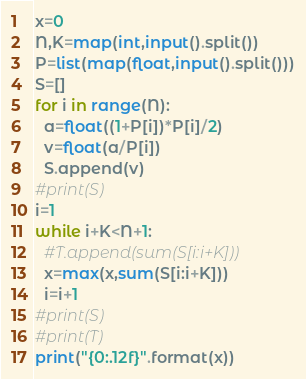Convert code to text. <code><loc_0><loc_0><loc_500><loc_500><_Python_>x=0
N,K=map(int,input().split())
P=list(map(float,input().split()))
S=[]
for i in range(N):
  a=float((1+P[i])*P[i]/2)
  v=float(a/P[i])
  S.append(v)
#print(S)
i=1
while i+K<N+1:
  #T.append(sum(S[i:i+K]))
  x=max(x,sum(S[i:i+K]))
  i=i+1
#print(S)
#print(T)
print("{0:.12f}".format(x))</code> 